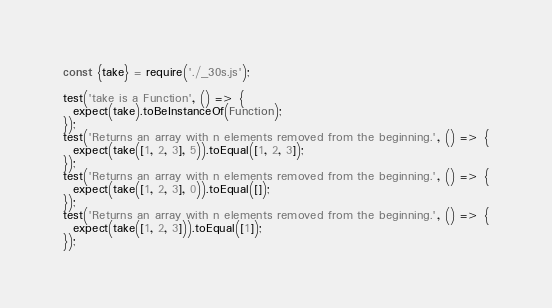Convert code to text. <code><loc_0><loc_0><loc_500><loc_500><_JavaScript_>const {take} = require('./_30s.js');

test('take is a Function', () => {
  expect(take).toBeInstanceOf(Function);
});
test('Returns an array with n elements removed from the beginning.', () => {
  expect(take([1, 2, 3], 5)).toEqual([1, 2, 3]);
});
test('Returns an array with n elements removed from the beginning.', () => {
  expect(take([1, 2, 3], 0)).toEqual([]);
});
test('Returns an array with n elements removed from the beginning.', () => {
  expect(take([1, 2, 3])).toEqual([1]);
});
</code> 